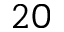Convert formula to latex. <formula><loc_0><loc_0><loc_500><loc_500>2 0</formula> 